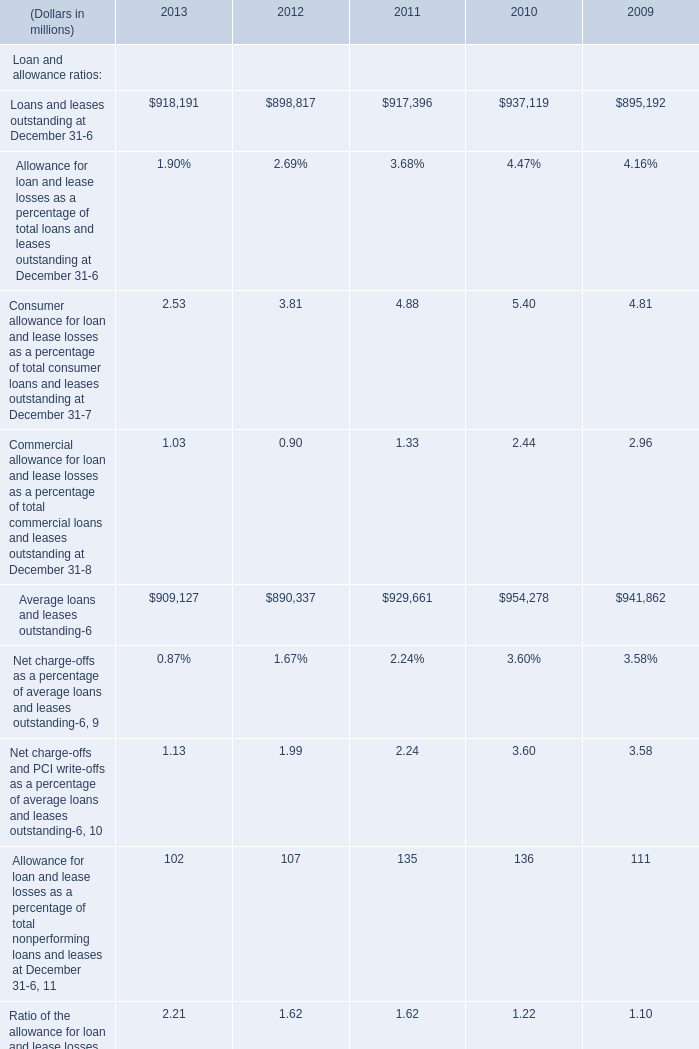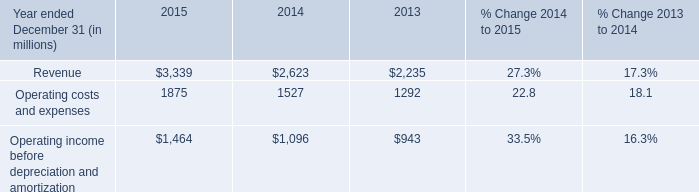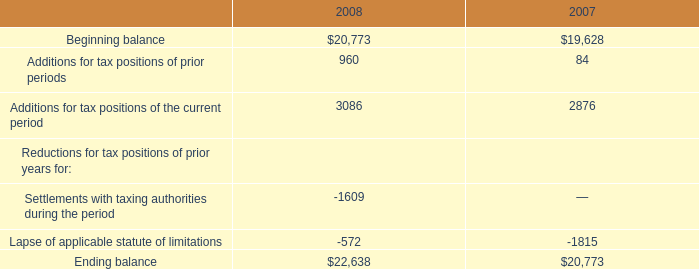What's the sum of Operating income before depreciation and amortization of 2014, Average loans and leases outstanding of 2010, and Loans and leases outstanding at December 31 of 2013 ? 
Computations: ((1096.0 + 954278.0) + 918191.0)
Answer: 1873565.0. 